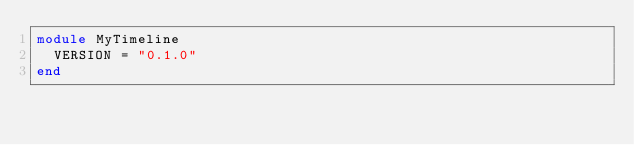<code> <loc_0><loc_0><loc_500><loc_500><_Ruby_>module MyTimeline
  VERSION = "0.1.0"
end
</code> 